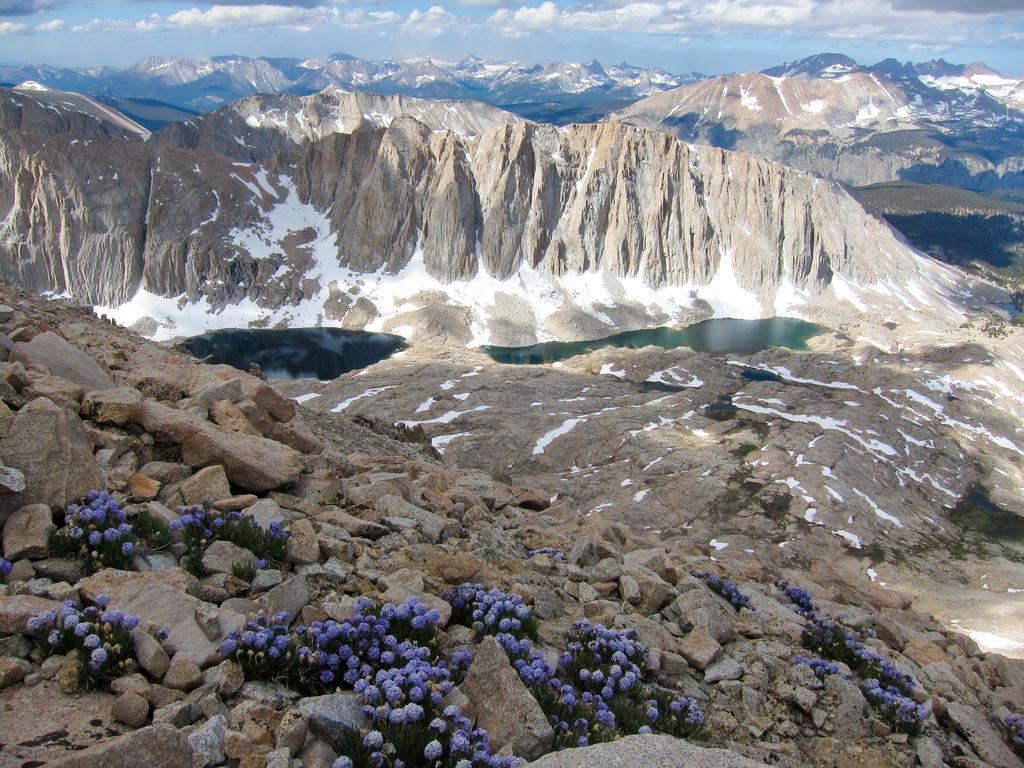How would you summarize this image in a sentence or two? In this picture I can observe lake in the middle of the picture. In the bottom of the picture I can observe rocks. In the background there are hills and some clouds in the sky. 